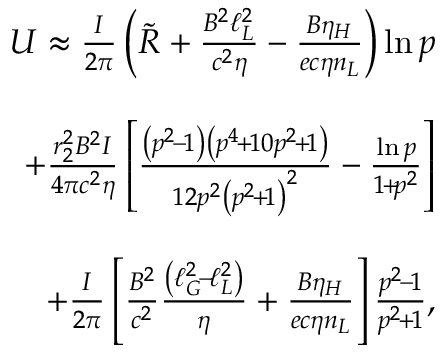Convert formula to latex. <formula><loc_0><loc_0><loc_500><loc_500>\begin{array} { r l r } & { U \approx \frac { I } { 2 \pi } \left ( \tilde { R } + \frac { B ^ { 2 } \ell _ { L } ^ { 2 } } { c ^ { 2 } \eta } - \frac { B \eta _ { H } } { e c \eta n _ { L } } \right ) \ln p } \\ & \\ & { \quad + \frac { r _ { 2 } ^ { 2 } B ^ { 2 } I } { 4 \pi c ^ { 2 } \eta } \left [ \frac { \left ( p ^ { 2 } \, - \, 1 \right ) \left ( p ^ { 4 } \, + \, 1 0 p ^ { 2 } \, + \, 1 \right ) } { 1 2 p ^ { 2 } \left ( p ^ { 2 } \, + \, 1 \right ) ^ { 2 } } - \frac { \ln p } { 1 \, + \, p ^ { 2 } } \right ] } \\ & \\ & { \quad + \frac { I } { 2 \pi } \left [ \frac { B ^ { 2 } } { c ^ { 2 } } \frac { \left ( \ell _ { G } ^ { 2 } \, - \, \ell _ { L } ^ { 2 } \right ) } { \eta } + \frac { B \eta _ { H } } { e c \eta n _ { L } } \right ] \frac { p ^ { 2 } \, - \, 1 } { p ^ { 2 } \, + \, 1 } , } \end{array}</formula> 